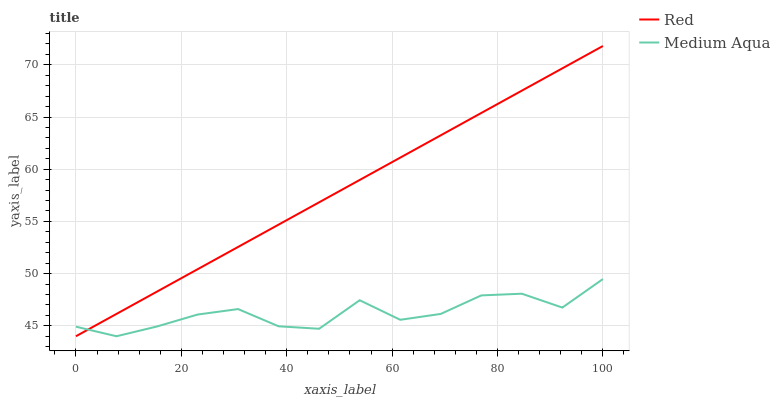Does Medium Aqua have the minimum area under the curve?
Answer yes or no. Yes. Does Red have the maximum area under the curve?
Answer yes or no. Yes. Does Red have the minimum area under the curve?
Answer yes or no. No. Is Red the smoothest?
Answer yes or no. Yes. Is Medium Aqua the roughest?
Answer yes or no. Yes. Is Red the roughest?
Answer yes or no. No. Does Medium Aqua have the lowest value?
Answer yes or no. Yes. Does Red have the highest value?
Answer yes or no. Yes. Does Medium Aqua intersect Red?
Answer yes or no. Yes. Is Medium Aqua less than Red?
Answer yes or no. No. Is Medium Aqua greater than Red?
Answer yes or no. No. 